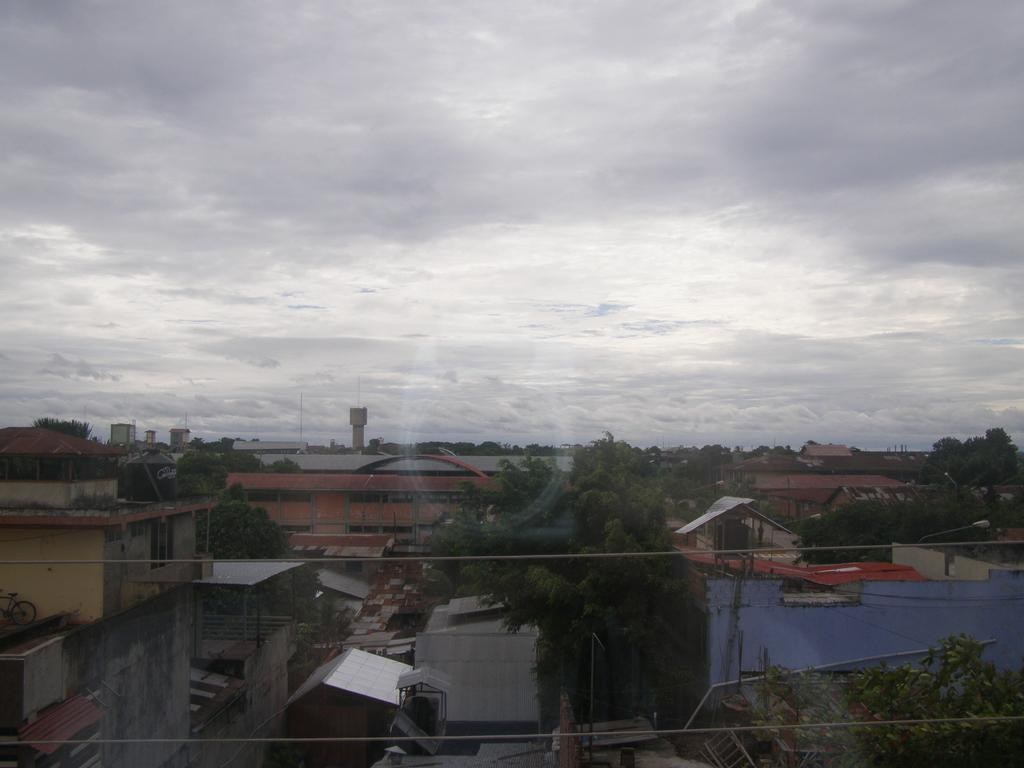What type of location is depicted in the image? There is a street in the image. What structures can be seen along the street? There are houses and buildings along the street. What type of vegetation is present along the street? Trees are present along the street. What else can be seen along the street? There are poles along the street. What is visible in the background of the image? The sky is visible in the background of the image. What can be observed in the sky? Clouds are present in the sky. What type of wine is being served at the fire station in the image? There is no fire station or wine present in the image. What type of thread is being used to sew the fireman's uniform in the image? There is no fireman or uniform present in the image. 